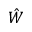Convert formula to latex. <formula><loc_0><loc_0><loc_500><loc_500>\hat { W }</formula> 